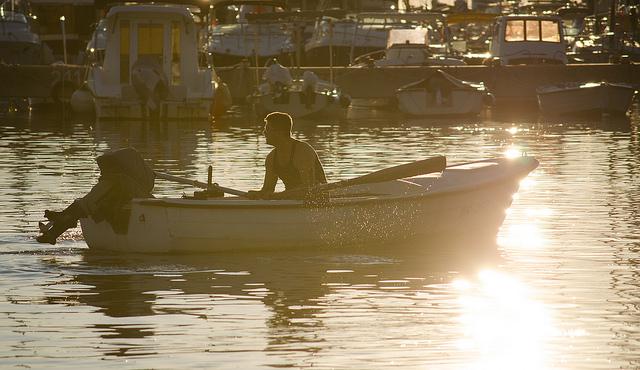Is the boat rower alive or dead?
Quick response, please. Alive. Is there 2 people in the boat?
Answer briefly. No. What kind of motor does the boat have?
Answer briefly. Outboard. 